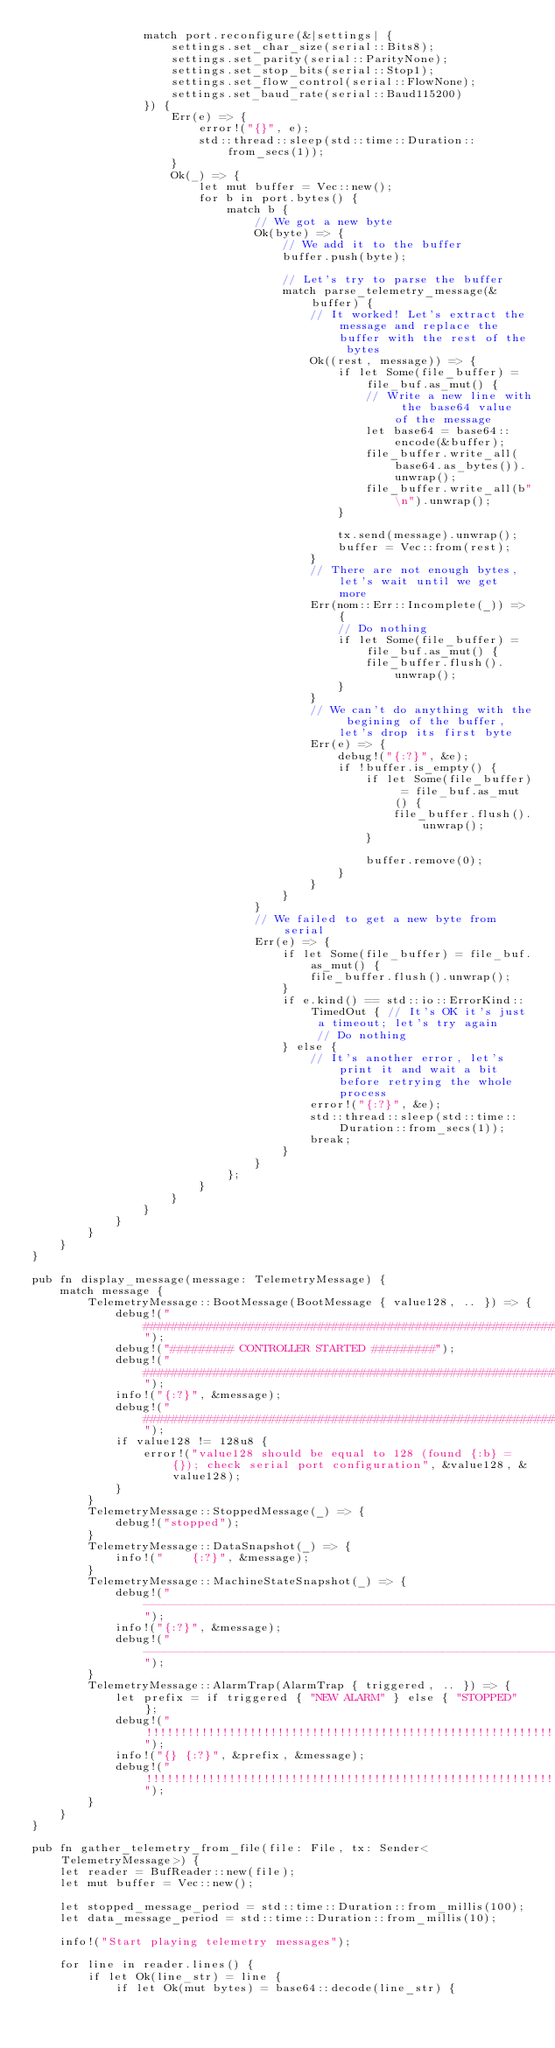<code> <loc_0><loc_0><loc_500><loc_500><_Rust_>                match port.reconfigure(&|settings| {
                    settings.set_char_size(serial::Bits8);
                    settings.set_parity(serial::ParityNone);
                    settings.set_stop_bits(serial::Stop1);
                    settings.set_flow_control(serial::FlowNone);
                    settings.set_baud_rate(serial::Baud115200)
                }) {
                    Err(e) => {
                        error!("{}", e);
                        std::thread::sleep(std::time::Duration::from_secs(1));
                    }
                    Ok(_) => {
                        let mut buffer = Vec::new();
                        for b in port.bytes() {
                            match b {
                                // We got a new byte
                                Ok(byte) => {
                                    // We add it to the buffer
                                    buffer.push(byte);

                                    // Let's try to parse the buffer
                                    match parse_telemetry_message(&buffer) {
                                        // It worked! Let's extract the message and replace the buffer with the rest of the bytes
                                        Ok((rest, message)) => {
                                            if let Some(file_buffer) = file_buf.as_mut() {
                                                // Write a new line with the base64 value of the message
                                                let base64 = base64::encode(&buffer);
                                                file_buffer.write_all(base64.as_bytes()).unwrap();
                                                file_buffer.write_all(b"\n").unwrap();
                                            }

                                            tx.send(message).unwrap();
                                            buffer = Vec::from(rest);
                                        }
                                        // There are not enough bytes, let's wait until we get more
                                        Err(nom::Err::Incomplete(_)) => {
                                            // Do nothing
                                            if let Some(file_buffer) = file_buf.as_mut() {
                                                file_buffer.flush().unwrap();
                                            }
                                        }
                                        // We can't do anything with the begining of the buffer, let's drop its first byte
                                        Err(e) => {
                                            debug!("{:?}", &e);
                                            if !buffer.is_empty() {
                                                if let Some(file_buffer) = file_buf.as_mut() {
                                                    file_buffer.flush().unwrap();
                                                }

                                                buffer.remove(0);
                                            }
                                        }
                                    }
                                }
                                // We failed to get a new byte from serial
                                Err(e) => {
                                    if let Some(file_buffer) = file_buf.as_mut() {
                                        file_buffer.flush().unwrap();
                                    }
                                    if e.kind() == std::io::ErrorKind::TimedOut { // It's OK it's just a timeout; let's try again
                                         // Do nothing
                                    } else {
                                        // It's another error, let's print it and wait a bit before retrying the whole process
                                        error!("{:?}", &e);
                                        std::thread::sleep(std::time::Duration::from_secs(1));
                                        break;
                                    }
                                }
                            };
                        }
                    }
                }
            }
        }
    }
}

pub fn display_message(message: TelemetryMessage) {
    match message {
        TelemetryMessage::BootMessage(BootMessage { value128, .. }) => {
            debug!("####################################################################################");
            debug!("######### CONTROLLER STARTED #########");
            debug!("####################################################################################");
            info!("{:?}", &message);
            debug!("####################################################################################");
            if value128 != 128u8 {
                error!("value128 should be equal to 128 (found {:b} = {}); check serial port configuration", &value128, &value128);
            }
        }
        TelemetryMessage::StoppedMessage(_) => {
            debug!("stopped");
        }
        TelemetryMessage::DataSnapshot(_) => {
            info!("    {:?}", &message);
        }
        TelemetryMessage::MachineStateSnapshot(_) => {
            debug!("------------------------------------------------------------------------------------");
            info!("{:?}", &message);
            debug!("------------------------------------------------------------------------------------");
        }
        TelemetryMessage::AlarmTrap(AlarmTrap { triggered, .. }) => {
            let prefix = if triggered { "NEW ALARM" } else { "STOPPED" };
            debug!("!!!!!!!!!!!!!!!!!!!!!!!!!!!!!!!!!!!!!!!!!!!!!!!!!!!!!!!!!!!!!!!!!!!!!!!!!!!!!!!!!!!!");
            info!("{} {:?}", &prefix, &message);
            debug!("!!!!!!!!!!!!!!!!!!!!!!!!!!!!!!!!!!!!!!!!!!!!!!!!!!!!!!!!!!!!!!!!!!!!!!!!!!!!!!!!!!!!");
        }
    }
}

pub fn gather_telemetry_from_file(file: File, tx: Sender<TelemetryMessage>) {
    let reader = BufReader::new(file);
    let mut buffer = Vec::new();

    let stopped_message_period = std::time::Duration::from_millis(100);
    let data_message_period = std::time::Duration::from_millis(10);

    info!("Start playing telemetry messages");

    for line in reader.lines() {
        if let Ok(line_str) = line {
            if let Ok(mut bytes) = base64::decode(line_str) {</code> 